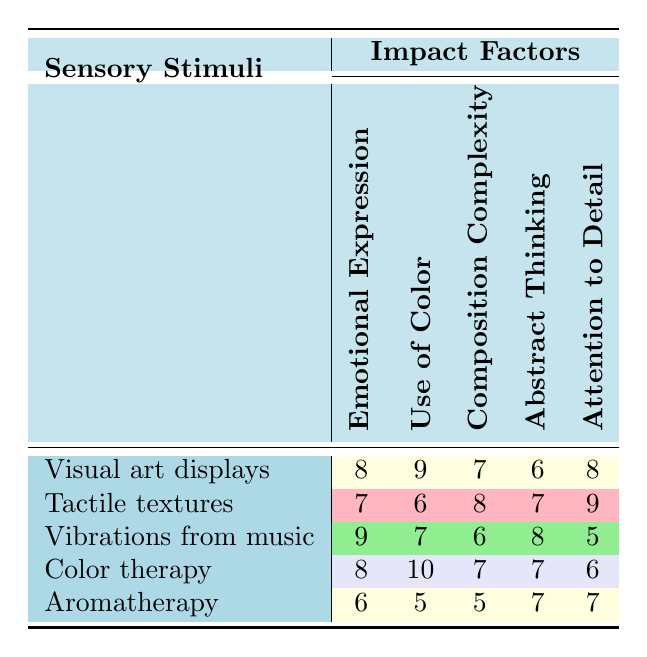What is the highest score for emotional expression? The highest score for emotional expression among the sensory stimuli is found by checking the values in the Emotional Expression column. Visual art displays and vibrations from music both have a score of 9, which is the highest.
Answer: 9 Which sensory stimulus received the lowest score for attention to detail? To find the lowest score for attention to detail, I look down the Attention to Detail column. The score of 5 from vibrations from music is the lowest compared to the other stimuli in that category.
Answer: 5 What is the difference between the highest and lowest scores for use of color? The highest score for use of color is 10 from color therapy, and the lowest score is 5 from aromatherapy. To find the difference, I subtract the lowest from the highest: 10 - 5 = 5.
Answer: 5 True or False: Tactile textures have a higher score in composition complexity than vibrations from music. Checking the Composition Complexity column, tactile textures have a score of 8 and vibrations from music have a score of 6. Since 8 is greater than 6, the statement is true.
Answer: True What is the average score for abstract thinking across all sensory stimuli? To find the average score for abstract thinking, I sum the scores in the Abstract Thinking column (6 + 7 + 8 + 7 + 7 = 35) and divide by the number of stimuli (5): 35 / 5 = 7.
Answer: 7 